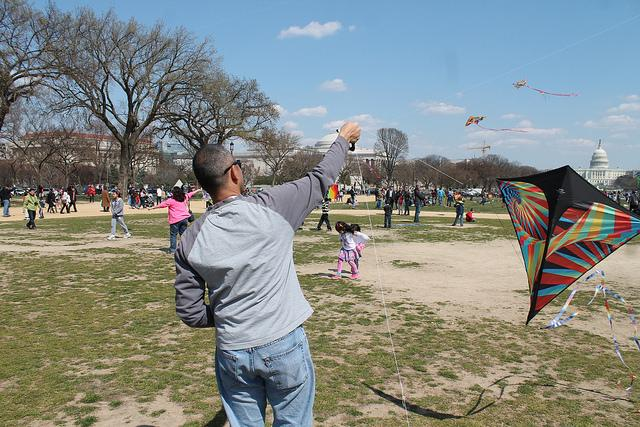Where would more well known government workers work here? capitol 